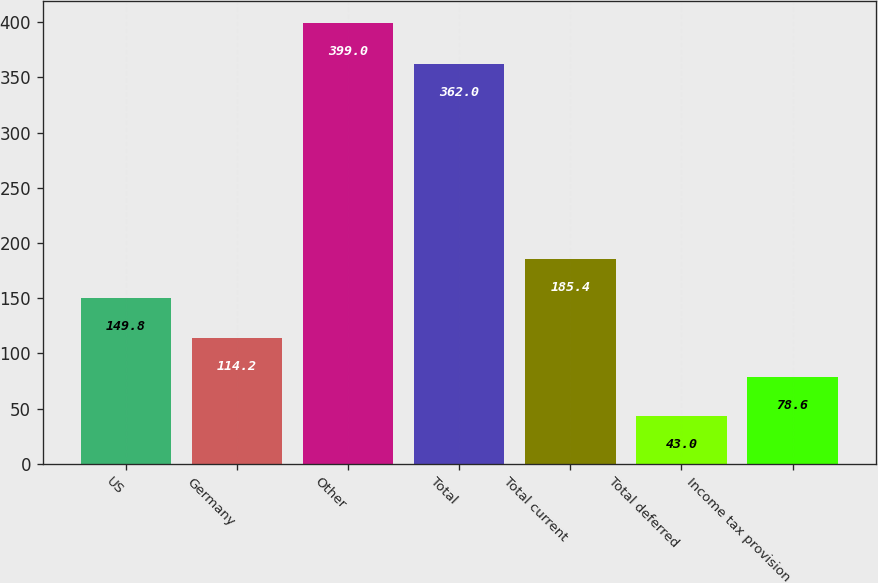Convert chart. <chart><loc_0><loc_0><loc_500><loc_500><bar_chart><fcel>US<fcel>Germany<fcel>Other<fcel>Total<fcel>Total current<fcel>Total deferred<fcel>Income tax provision<nl><fcel>149.8<fcel>114.2<fcel>399<fcel>362<fcel>185.4<fcel>43<fcel>78.6<nl></chart> 